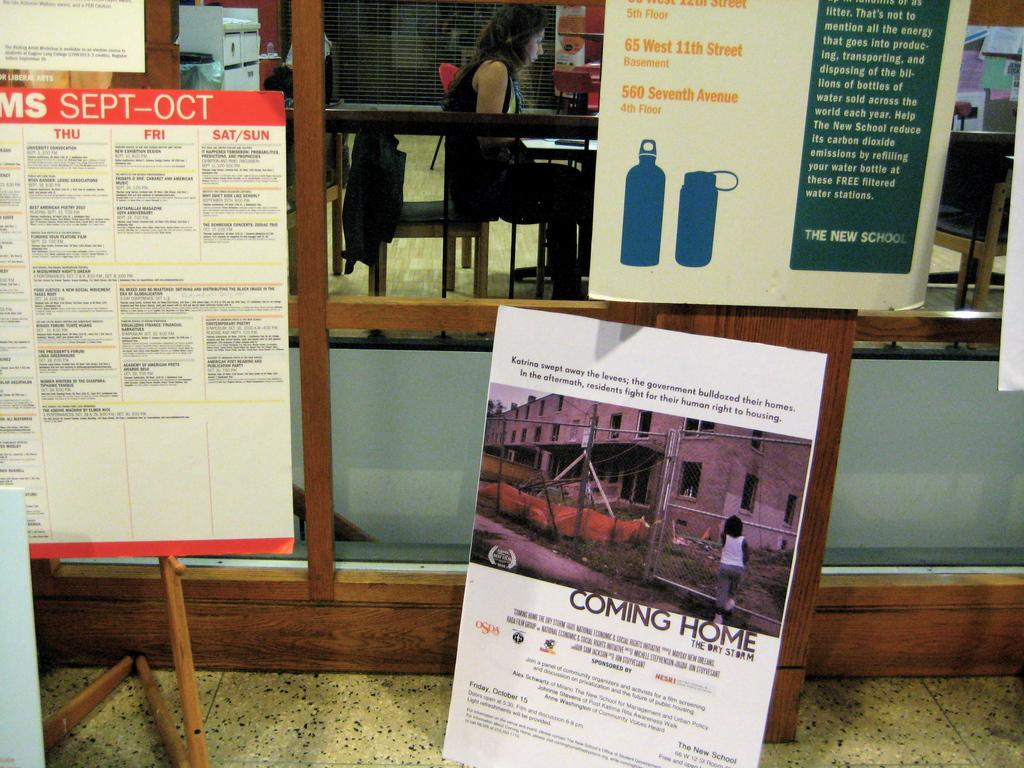Provide a one-sentence caption for the provided image. Several posters, including one titled "COMING HOME" are on display. 